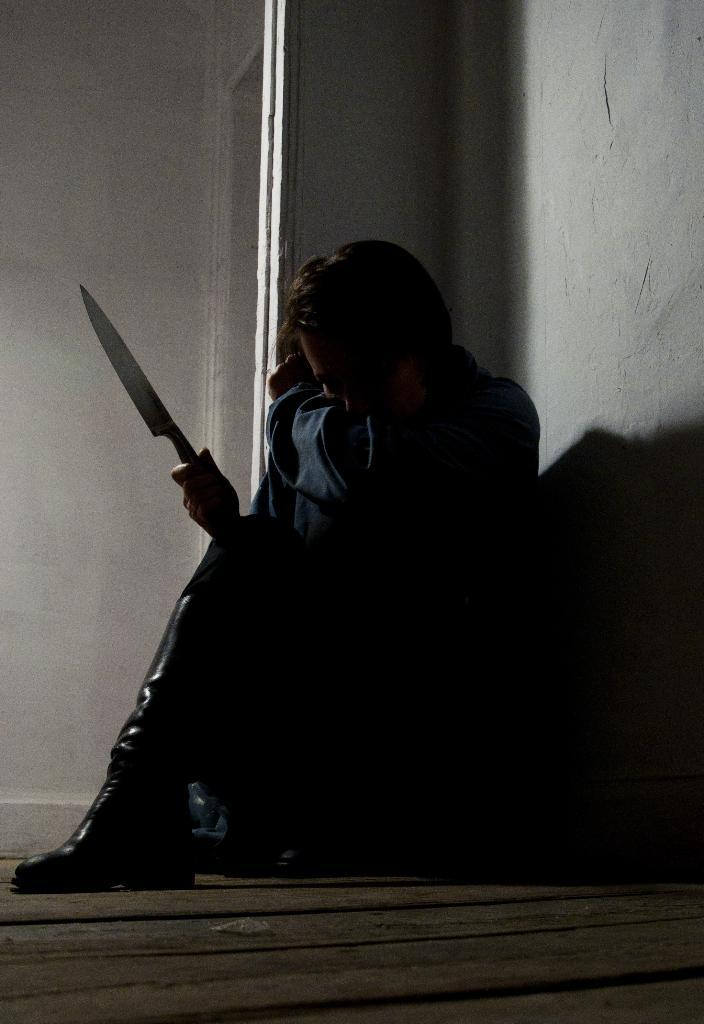What is the person in the image doing? The person is sitting on the floor in the image. What object is the person holding in his hand? The person is holding a knife in his hand. What can be seen in the background of the image? There is a wall in the background of the image. What type of car is parked next to the person in the image? There is no car present in the image; it only features a person sitting on the floor and a wall in the background. 